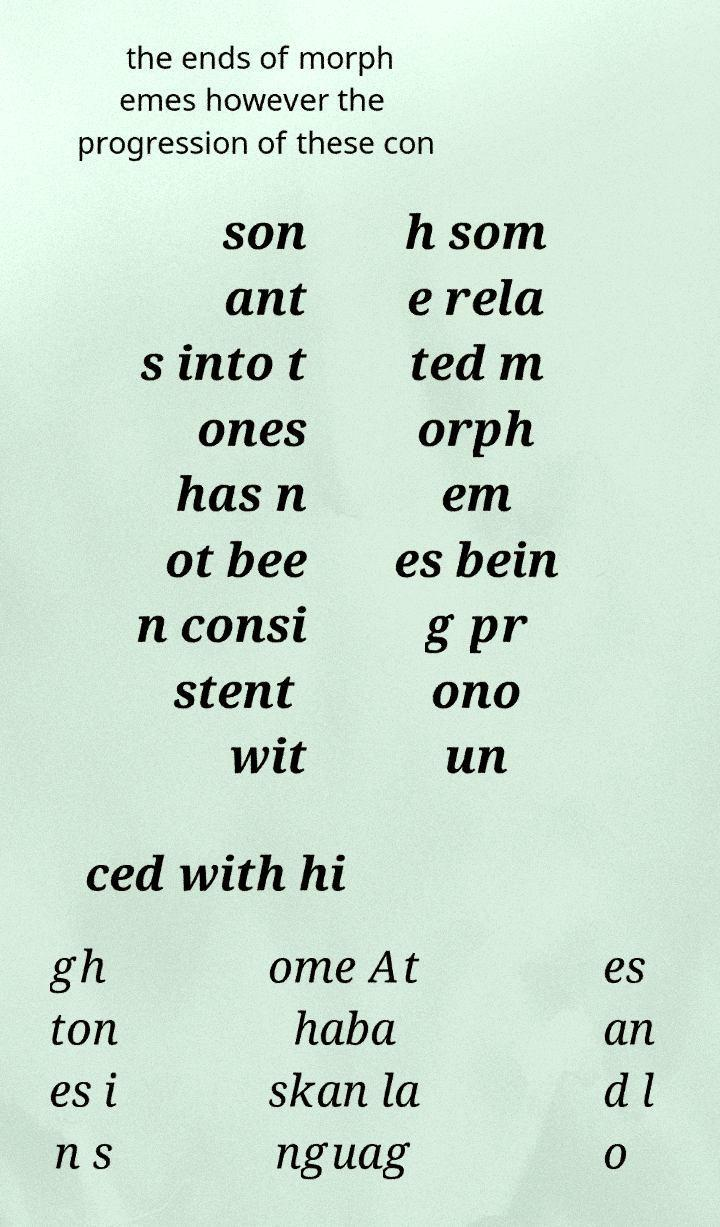For documentation purposes, I need the text within this image transcribed. Could you provide that? the ends of morph emes however the progression of these con son ant s into t ones has n ot bee n consi stent wit h som e rela ted m orph em es bein g pr ono un ced with hi gh ton es i n s ome At haba skan la nguag es an d l o 